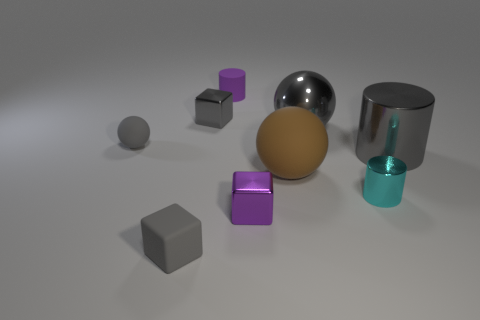Subtract all cubes. How many objects are left? 6 Subtract all gray rubber things. Subtract all brown things. How many objects are left? 6 Add 9 tiny cyan cylinders. How many tiny cyan cylinders are left? 10 Add 7 tiny matte things. How many tiny matte things exist? 10 Subtract 1 purple blocks. How many objects are left? 8 